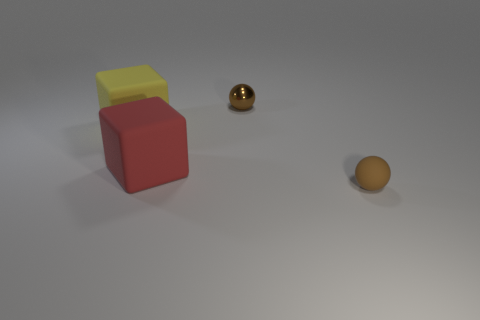How many objects are there in total? In the image, there are three objects in total. We have two cube-like objects stacked on top of each other and one spherical object. Do the cubes seem like they belong to one set or do they have different textures? The two cubes, one red and one yellow, appear to have similar matte textures, suggesting they could belong to the same set, although their distinct colors might indicate different purposes or categories within the set. 